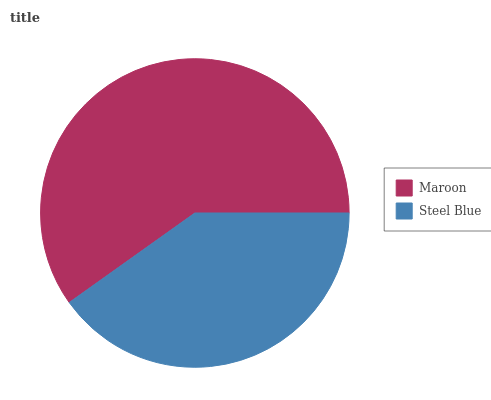Is Steel Blue the minimum?
Answer yes or no. Yes. Is Maroon the maximum?
Answer yes or no. Yes. Is Steel Blue the maximum?
Answer yes or no. No. Is Maroon greater than Steel Blue?
Answer yes or no. Yes. Is Steel Blue less than Maroon?
Answer yes or no. Yes. Is Steel Blue greater than Maroon?
Answer yes or no. No. Is Maroon less than Steel Blue?
Answer yes or no. No. Is Maroon the high median?
Answer yes or no. Yes. Is Steel Blue the low median?
Answer yes or no. Yes. Is Steel Blue the high median?
Answer yes or no. No. Is Maroon the low median?
Answer yes or no. No. 